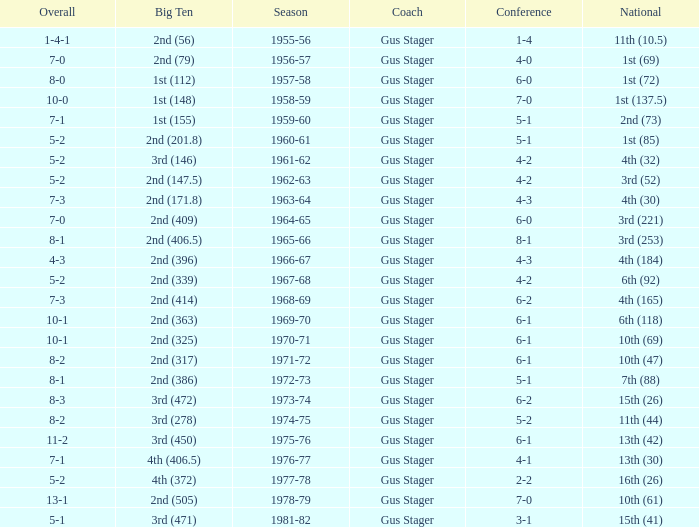What is the Coach with a Big Ten that is 3rd (278)? Gus Stager. 